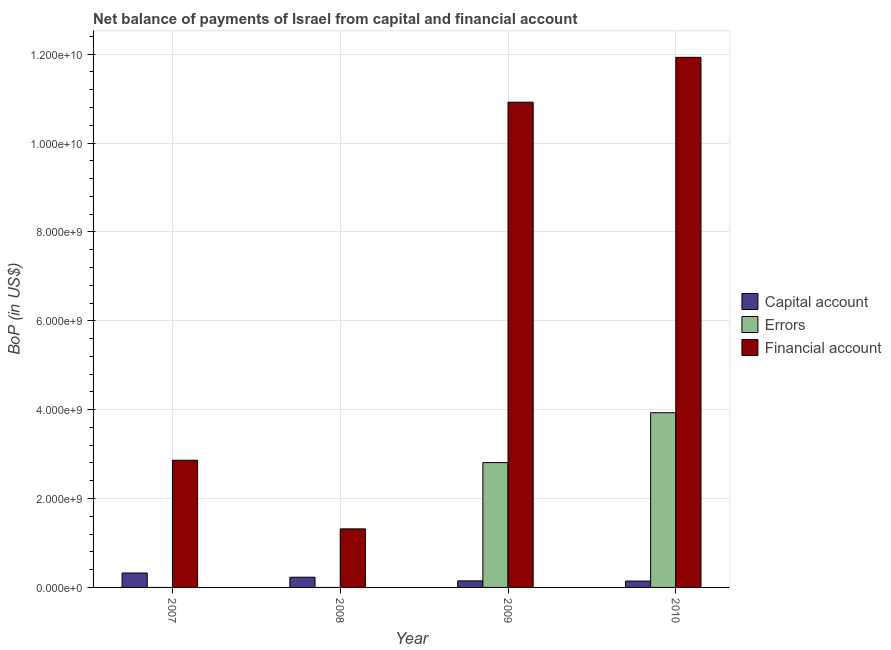How many groups of bars are there?
Offer a terse response. 4. Are the number of bars per tick equal to the number of legend labels?
Offer a terse response. No. Are the number of bars on each tick of the X-axis equal?
Your answer should be very brief. No. How many bars are there on the 2nd tick from the left?
Your response must be concise. 2. What is the label of the 4th group of bars from the left?
Keep it short and to the point. 2010. What is the amount of errors in 2007?
Your response must be concise. 0. Across all years, what is the maximum amount of financial account?
Your response must be concise. 1.19e+1. Across all years, what is the minimum amount of financial account?
Offer a terse response. 1.32e+09. In which year was the amount of errors maximum?
Your answer should be very brief. 2010. What is the total amount of financial account in the graph?
Make the answer very short. 2.70e+1. What is the difference between the amount of financial account in 2008 and that in 2010?
Make the answer very short. -1.06e+1. What is the difference between the amount of errors in 2007 and the amount of net capital account in 2008?
Your answer should be compact. 0. What is the average amount of financial account per year?
Make the answer very short. 6.76e+09. In the year 2008, what is the difference between the amount of financial account and amount of errors?
Provide a succinct answer. 0. What is the ratio of the amount of financial account in 2008 to that in 2009?
Provide a succinct answer. 0.12. Is the amount of net capital account in 2008 less than that in 2009?
Your answer should be compact. No. What is the difference between the highest and the second highest amount of net capital account?
Your response must be concise. 9.53e+07. What is the difference between the highest and the lowest amount of errors?
Offer a very short reply. 3.93e+09. Is it the case that in every year, the sum of the amount of net capital account and amount of errors is greater than the amount of financial account?
Offer a very short reply. No. How many bars are there?
Give a very brief answer. 10. Are all the bars in the graph horizontal?
Make the answer very short. No. How many years are there in the graph?
Make the answer very short. 4. Are the values on the major ticks of Y-axis written in scientific E-notation?
Provide a short and direct response. Yes. Does the graph contain any zero values?
Ensure brevity in your answer.  Yes. Does the graph contain grids?
Offer a very short reply. Yes. How many legend labels are there?
Provide a succinct answer. 3. What is the title of the graph?
Your answer should be compact. Net balance of payments of Israel from capital and financial account. What is the label or title of the X-axis?
Keep it short and to the point. Year. What is the label or title of the Y-axis?
Offer a very short reply. BoP (in US$). What is the BoP (in US$) in Capital account in 2007?
Offer a terse response. 3.25e+08. What is the BoP (in US$) in Errors in 2007?
Your response must be concise. 0. What is the BoP (in US$) of Financial account in 2007?
Your answer should be compact. 2.86e+09. What is the BoP (in US$) of Capital account in 2008?
Offer a very short reply. 2.30e+08. What is the BoP (in US$) of Financial account in 2008?
Make the answer very short. 1.32e+09. What is the BoP (in US$) of Capital account in 2009?
Keep it short and to the point. 1.48e+08. What is the BoP (in US$) in Errors in 2009?
Offer a very short reply. 2.81e+09. What is the BoP (in US$) of Financial account in 2009?
Make the answer very short. 1.09e+1. What is the BoP (in US$) of Capital account in 2010?
Ensure brevity in your answer.  1.43e+08. What is the BoP (in US$) in Errors in 2010?
Offer a very short reply. 3.93e+09. What is the BoP (in US$) of Financial account in 2010?
Your answer should be compact. 1.19e+1. Across all years, what is the maximum BoP (in US$) of Capital account?
Give a very brief answer. 3.25e+08. Across all years, what is the maximum BoP (in US$) of Errors?
Your answer should be very brief. 3.93e+09. Across all years, what is the maximum BoP (in US$) of Financial account?
Provide a succinct answer. 1.19e+1. Across all years, what is the minimum BoP (in US$) in Capital account?
Your response must be concise. 1.43e+08. Across all years, what is the minimum BoP (in US$) of Errors?
Your answer should be compact. 0. Across all years, what is the minimum BoP (in US$) in Financial account?
Your answer should be compact. 1.32e+09. What is the total BoP (in US$) of Capital account in the graph?
Make the answer very short. 8.45e+08. What is the total BoP (in US$) of Errors in the graph?
Give a very brief answer. 6.74e+09. What is the total BoP (in US$) of Financial account in the graph?
Provide a short and direct response. 2.70e+1. What is the difference between the BoP (in US$) in Capital account in 2007 and that in 2008?
Your response must be concise. 9.53e+07. What is the difference between the BoP (in US$) in Financial account in 2007 and that in 2008?
Offer a terse response. 1.54e+09. What is the difference between the BoP (in US$) of Capital account in 2007 and that in 2009?
Give a very brief answer. 1.77e+08. What is the difference between the BoP (in US$) in Financial account in 2007 and that in 2009?
Offer a terse response. -8.06e+09. What is the difference between the BoP (in US$) of Capital account in 2007 and that in 2010?
Offer a very short reply. 1.82e+08. What is the difference between the BoP (in US$) of Financial account in 2007 and that in 2010?
Make the answer very short. -9.07e+09. What is the difference between the BoP (in US$) in Capital account in 2008 and that in 2009?
Keep it short and to the point. 8.19e+07. What is the difference between the BoP (in US$) of Financial account in 2008 and that in 2009?
Provide a short and direct response. -9.60e+09. What is the difference between the BoP (in US$) in Capital account in 2008 and that in 2010?
Give a very brief answer. 8.67e+07. What is the difference between the BoP (in US$) of Financial account in 2008 and that in 2010?
Your response must be concise. -1.06e+1. What is the difference between the BoP (in US$) in Capital account in 2009 and that in 2010?
Keep it short and to the point. 4.80e+06. What is the difference between the BoP (in US$) of Errors in 2009 and that in 2010?
Ensure brevity in your answer.  -1.12e+09. What is the difference between the BoP (in US$) of Financial account in 2009 and that in 2010?
Your answer should be very brief. -1.01e+09. What is the difference between the BoP (in US$) in Capital account in 2007 and the BoP (in US$) in Financial account in 2008?
Make the answer very short. -9.92e+08. What is the difference between the BoP (in US$) of Capital account in 2007 and the BoP (in US$) of Errors in 2009?
Your answer should be very brief. -2.48e+09. What is the difference between the BoP (in US$) in Capital account in 2007 and the BoP (in US$) in Financial account in 2009?
Give a very brief answer. -1.06e+1. What is the difference between the BoP (in US$) of Capital account in 2007 and the BoP (in US$) of Errors in 2010?
Keep it short and to the point. -3.61e+09. What is the difference between the BoP (in US$) of Capital account in 2007 and the BoP (in US$) of Financial account in 2010?
Give a very brief answer. -1.16e+1. What is the difference between the BoP (in US$) in Capital account in 2008 and the BoP (in US$) in Errors in 2009?
Make the answer very short. -2.58e+09. What is the difference between the BoP (in US$) in Capital account in 2008 and the BoP (in US$) in Financial account in 2009?
Give a very brief answer. -1.07e+1. What is the difference between the BoP (in US$) of Capital account in 2008 and the BoP (in US$) of Errors in 2010?
Your answer should be very brief. -3.70e+09. What is the difference between the BoP (in US$) in Capital account in 2008 and the BoP (in US$) in Financial account in 2010?
Keep it short and to the point. -1.17e+1. What is the difference between the BoP (in US$) in Capital account in 2009 and the BoP (in US$) in Errors in 2010?
Your answer should be compact. -3.78e+09. What is the difference between the BoP (in US$) of Capital account in 2009 and the BoP (in US$) of Financial account in 2010?
Keep it short and to the point. -1.18e+1. What is the difference between the BoP (in US$) in Errors in 2009 and the BoP (in US$) in Financial account in 2010?
Give a very brief answer. -9.12e+09. What is the average BoP (in US$) of Capital account per year?
Make the answer very short. 2.11e+08. What is the average BoP (in US$) of Errors per year?
Offer a terse response. 1.68e+09. What is the average BoP (in US$) of Financial account per year?
Make the answer very short. 6.76e+09. In the year 2007, what is the difference between the BoP (in US$) in Capital account and BoP (in US$) in Financial account?
Offer a very short reply. -2.54e+09. In the year 2008, what is the difference between the BoP (in US$) in Capital account and BoP (in US$) in Financial account?
Provide a short and direct response. -1.09e+09. In the year 2009, what is the difference between the BoP (in US$) in Capital account and BoP (in US$) in Errors?
Keep it short and to the point. -2.66e+09. In the year 2009, what is the difference between the BoP (in US$) in Capital account and BoP (in US$) in Financial account?
Ensure brevity in your answer.  -1.08e+1. In the year 2009, what is the difference between the BoP (in US$) in Errors and BoP (in US$) in Financial account?
Your response must be concise. -8.11e+09. In the year 2010, what is the difference between the BoP (in US$) in Capital account and BoP (in US$) in Errors?
Provide a succinct answer. -3.79e+09. In the year 2010, what is the difference between the BoP (in US$) in Capital account and BoP (in US$) in Financial account?
Ensure brevity in your answer.  -1.18e+1. In the year 2010, what is the difference between the BoP (in US$) in Errors and BoP (in US$) in Financial account?
Your answer should be compact. -8.00e+09. What is the ratio of the BoP (in US$) of Capital account in 2007 to that in 2008?
Provide a succinct answer. 1.42. What is the ratio of the BoP (in US$) of Financial account in 2007 to that in 2008?
Your answer should be very brief. 2.17. What is the ratio of the BoP (in US$) of Capital account in 2007 to that in 2009?
Provide a short and direct response. 2.2. What is the ratio of the BoP (in US$) in Financial account in 2007 to that in 2009?
Your answer should be compact. 0.26. What is the ratio of the BoP (in US$) of Capital account in 2007 to that in 2010?
Make the answer very short. 2.27. What is the ratio of the BoP (in US$) in Financial account in 2007 to that in 2010?
Offer a terse response. 0.24. What is the ratio of the BoP (in US$) in Capital account in 2008 to that in 2009?
Give a very brief answer. 1.55. What is the ratio of the BoP (in US$) in Financial account in 2008 to that in 2009?
Offer a very short reply. 0.12. What is the ratio of the BoP (in US$) of Capital account in 2008 to that in 2010?
Offer a terse response. 1.61. What is the ratio of the BoP (in US$) of Financial account in 2008 to that in 2010?
Keep it short and to the point. 0.11. What is the ratio of the BoP (in US$) of Capital account in 2009 to that in 2010?
Keep it short and to the point. 1.03. What is the ratio of the BoP (in US$) of Errors in 2009 to that in 2010?
Your response must be concise. 0.71. What is the ratio of the BoP (in US$) of Financial account in 2009 to that in 2010?
Provide a short and direct response. 0.92. What is the difference between the highest and the second highest BoP (in US$) of Capital account?
Provide a short and direct response. 9.53e+07. What is the difference between the highest and the second highest BoP (in US$) of Financial account?
Your answer should be compact. 1.01e+09. What is the difference between the highest and the lowest BoP (in US$) in Capital account?
Offer a terse response. 1.82e+08. What is the difference between the highest and the lowest BoP (in US$) of Errors?
Provide a succinct answer. 3.93e+09. What is the difference between the highest and the lowest BoP (in US$) in Financial account?
Offer a very short reply. 1.06e+1. 